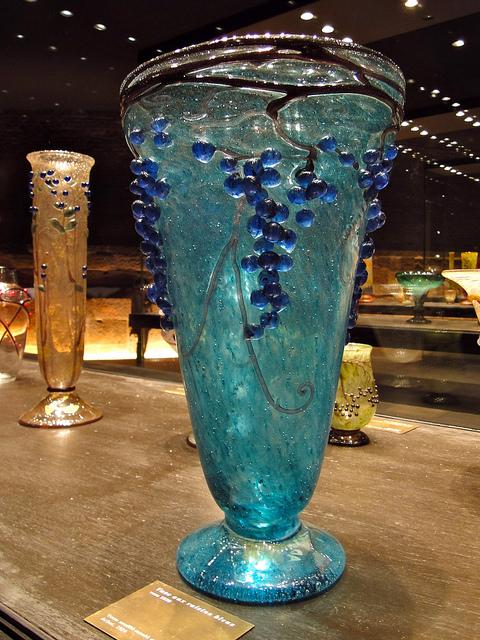What are those beads on the glass?
Write a very short answer. Glass. What color are the beads on the vase?
Concise answer only. Blue. What color is the vase?
Give a very brief answer. Blue. 